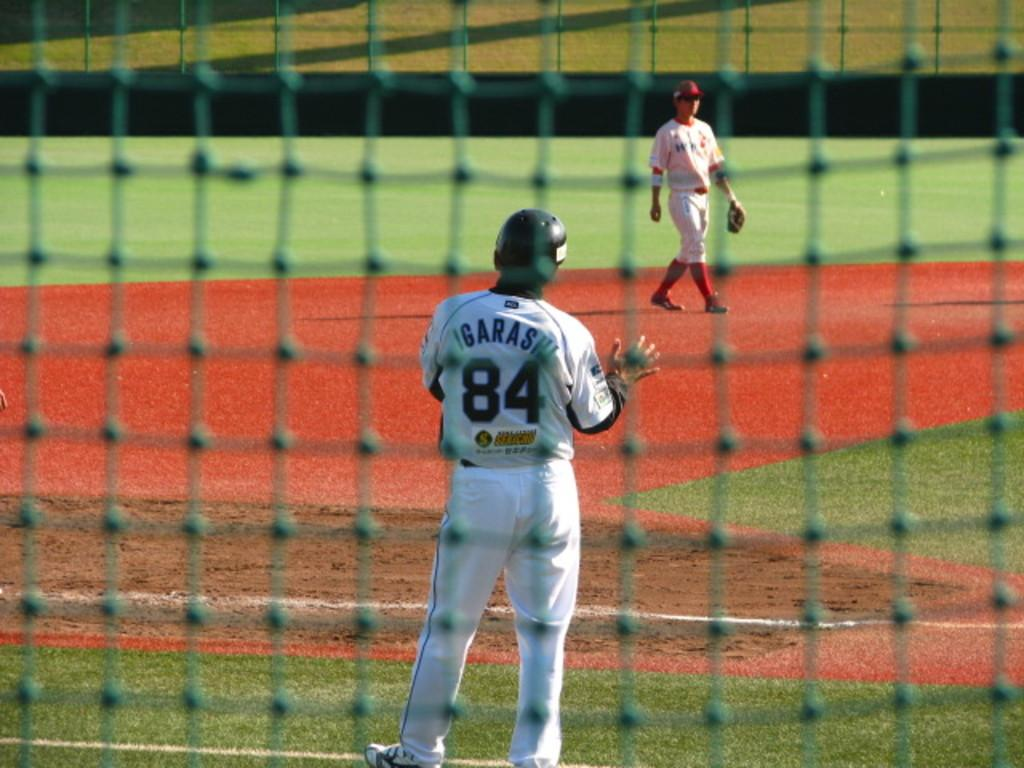<image>
Describe the image concisely. Two sports players, one of whom has the number 84 on the back of his shirt. 